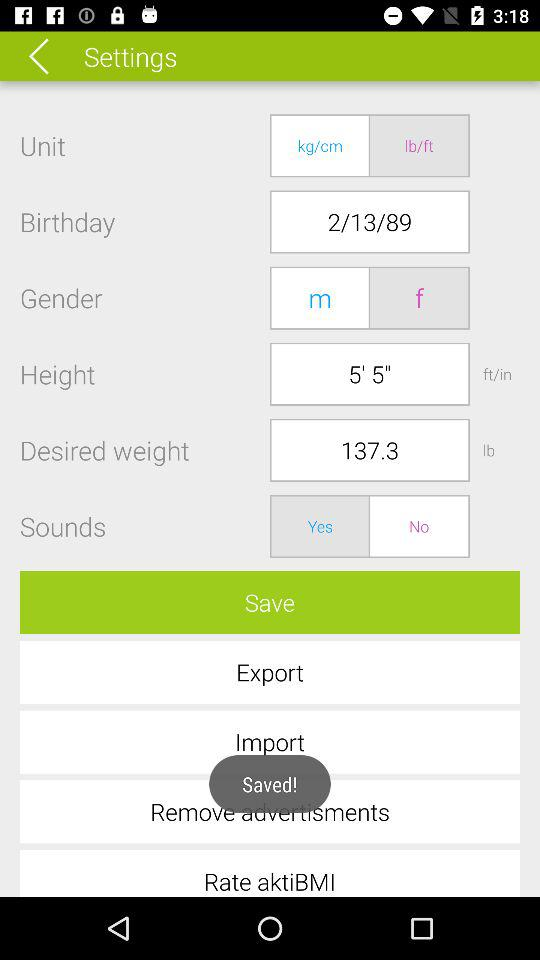What is the option for gender? The options are "m" and "f". 